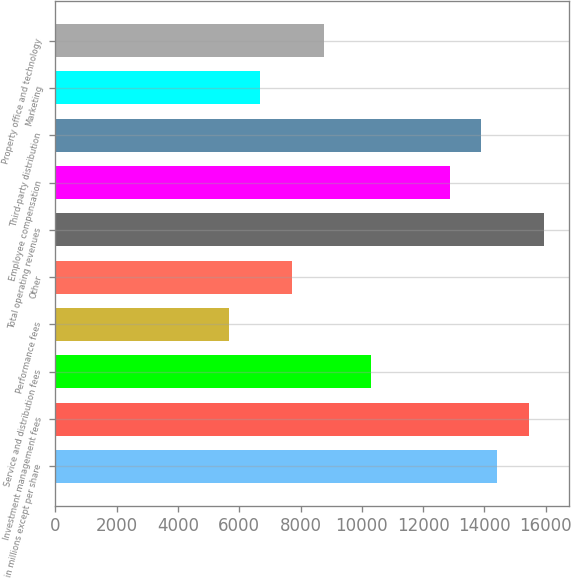Convert chart. <chart><loc_0><loc_0><loc_500><loc_500><bar_chart><fcel>in millions except per share<fcel>Investment management fees<fcel>Service and distribution fees<fcel>Performance fees<fcel>Other<fcel>Total operating revenues<fcel>Employee compensation<fcel>Third-party distribution<fcel>Marketing<fcel>Property office and technology<nl><fcel>14411.9<fcel>15441.3<fcel>10294.2<fcel>5661.82<fcel>7720.66<fcel>15956<fcel>12867.8<fcel>13897.2<fcel>6691.24<fcel>8750.08<nl></chart> 